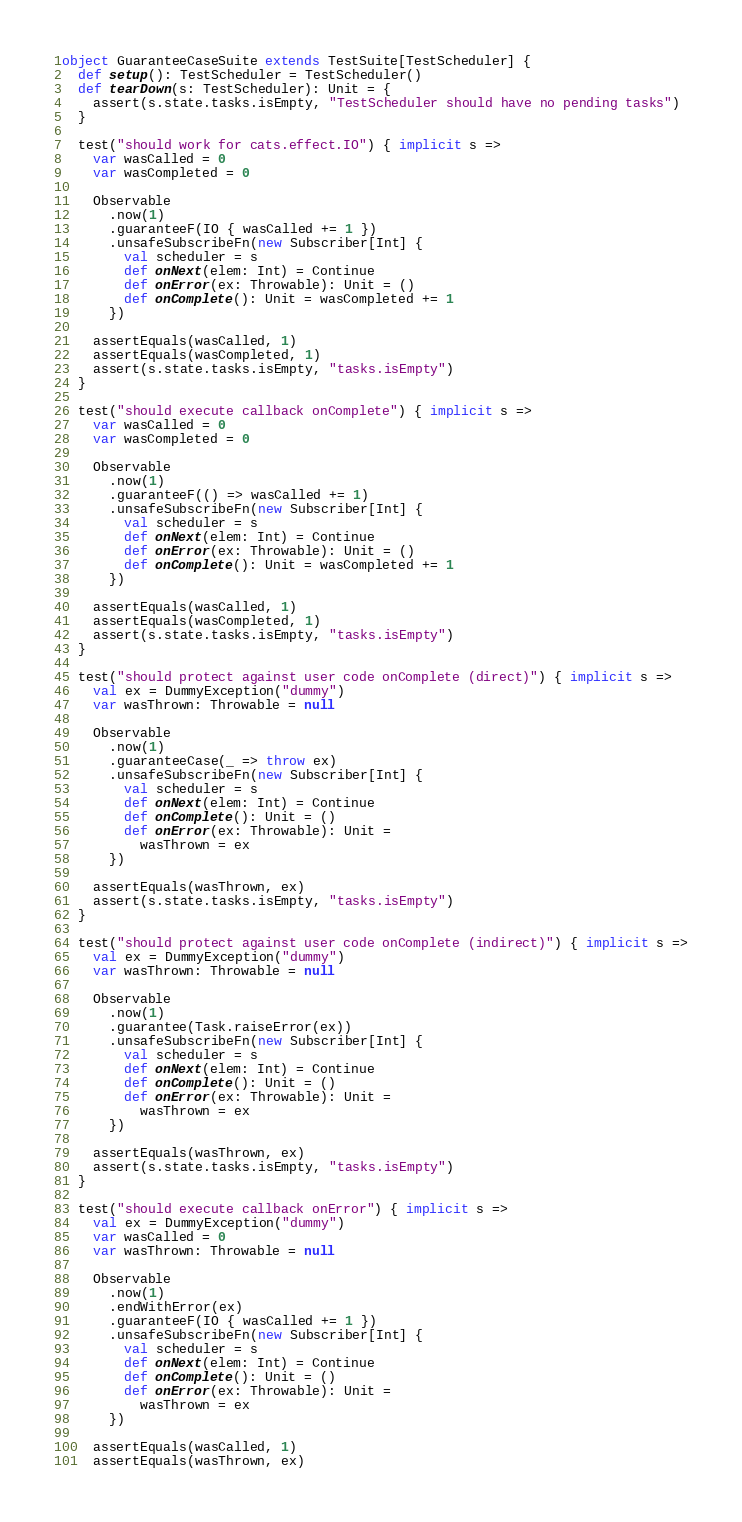<code> <loc_0><loc_0><loc_500><loc_500><_Scala_>object GuaranteeCaseSuite extends TestSuite[TestScheduler] {
  def setup(): TestScheduler = TestScheduler()
  def tearDown(s: TestScheduler): Unit = {
    assert(s.state.tasks.isEmpty, "TestScheduler should have no pending tasks")
  }

  test("should work for cats.effect.IO") { implicit s =>
    var wasCalled = 0
    var wasCompleted = 0

    Observable
      .now(1)
      .guaranteeF(IO { wasCalled += 1 })
      .unsafeSubscribeFn(new Subscriber[Int] {
        val scheduler = s
        def onNext(elem: Int) = Continue
        def onError(ex: Throwable): Unit = ()
        def onComplete(): Unit = wasCompleted += 1
      })

    assertEquals(wasCalled, 1)
    assertEquals(wasCompleted, 1)
    assert(s.state.tasks.isEmpty, "tasks.isEmpty")
  }

  test("should execute callback onComplete") { implicit s =>
    var wasCalled = 0
    var wasCompleted = 0

    Observable
      .now(1)
      .guaranteeF(() => wasCalled += 1)
      .unsafeSubscribeFn(new Subscriber[Int] {
        val scheduler = s
        def onNext(elem: Int) = Continue
        def onError(ex: Throwable): Unit = ()
        def onComplete(): Unit = wasCompleted += 1
      })

    assertEquals(wasCalled, 1)
    assertEquals(wasCompleted, 1)
    assert(s.state.tasks.isEmpty, "tasks.isEmpty")
  }

  test("should protect against user code onComplete (direct)") { implicit s =>
    val ex = DummyException("dummy")
    var wasThrown: Throwable = null

    Observable
      .now(1)
      .guaranteeCase(_ => throw ex)
      .unsafeSubscribeFn(new Subscriber[Int] {
        val scheduler = s
        def onNext(elem: Int) = Continue
        def onComplete(): Unit = ()
        def onError(ex: Throwable): Unit =
          wasThrown = ex
      })

    assertEquals(wasThrown, ex)
    assert(s.state.tasks.isEmpty, "tasks.isEmpty")
  }

  test("should protect against user code onComplete (indirect)") { implicit s =>
    val ex = DummyException("dummy")
    var wasThrown: Throwable = null

    Observable
      .now(1)
      .guarantee(Task.raiseError(ex))
      .unsafeSubscribeFn(new Subscriber[Int] {
        val scheduler = s
        def onNext(elem: Int) = Continue
        def onComplete(): Unit = ()
        def onError(ex: Throwable): Unit =
          wasThrown = ex
      })

    assertEquals(wasThrown, ex)
    assert(s.state.tasks.isEmpty, "tasks.isEmpty")
  }

  test("should execute callback onError") { implicit s =>
    val ex = DummyException("dummy")
    var wasCalled = 0
    var wasThrown: Throwable = null

    Observable
      .now(1)
      .endWithError(ex)
      .guaranteeF(IO { wasCalled += 1 })
      .unsafeSubscribeFn(new Subscriber[Int] {
        val scheduler = s
        def onNext(elem: Int) = Continue
        def onComplete(): Unit = ()
        def onError(ex: Throwable): Unit =
          wasThrown = ex
      })

    assertEquals(wasCalled, 1)
    assertEquals(wasThrown, ex)</code> 